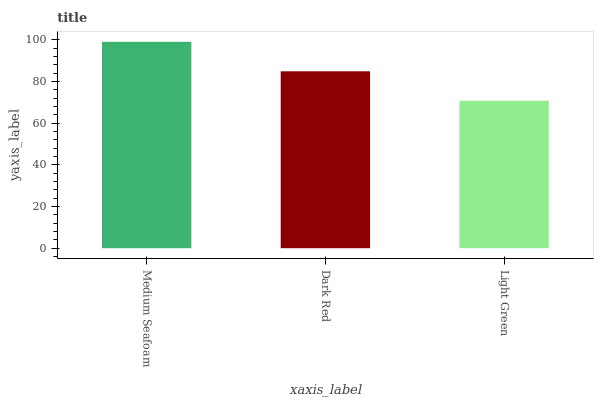Is Light Green the minimum?
Answer yes or no. Yes. Is Medium Seafoam the maximum?
Answer yes or no. Yes. Is Dark Red the minimum?
Answer yes or no. No. Is Dark Red the maximum?
Answer yes or no. No. Is Medium Seafoam greater than Dark Red?
Answer yes or no. Yes. Is Dark Red less than Medium Seafoam?
Answer yes or no. Yes. Is Dark Red greater than Medium Seafoam?
Answer yes or no. No. Is Medium Seafoam less than Dark Red?
Answer yes or no. No. Is Dark Red the high median?
Answer yes or no. Yes. Is Dark Red the low median?
Answer yes or no. Yes. Is Light Green the high median?
Answer yes or no. No. Is Medium Seafoam the low median?
Answer yes or no. No. 